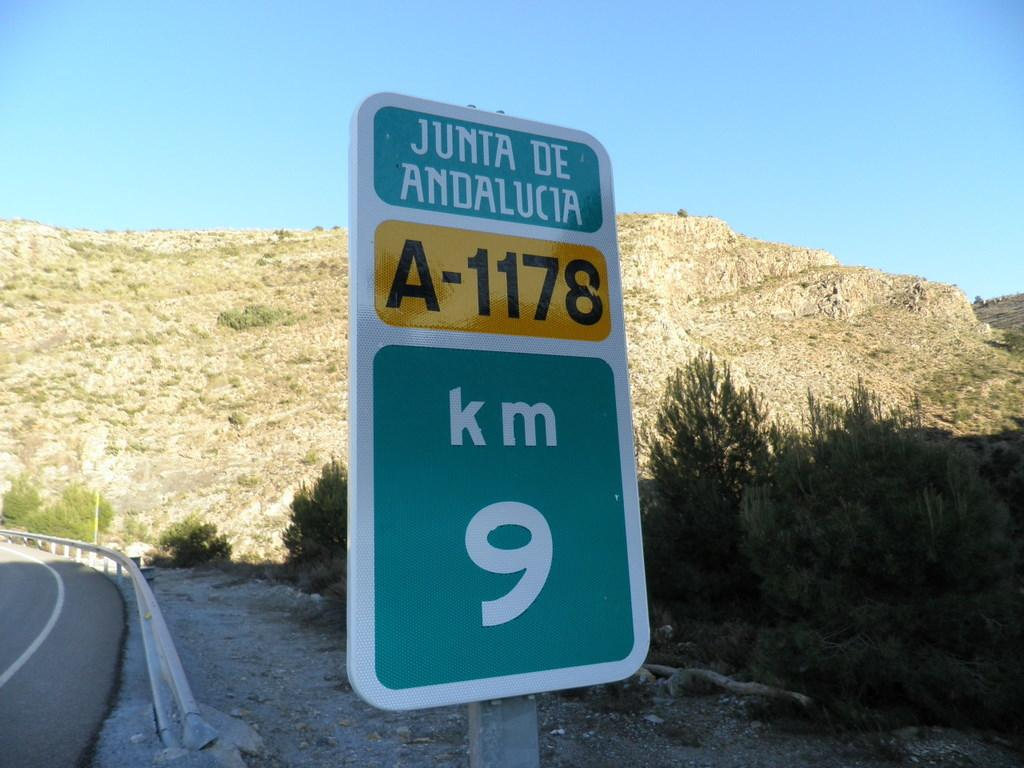<image>
Offer a succinct explanation of the picture presented. A road sign that says Junta de Andalucia is 9 km away. 